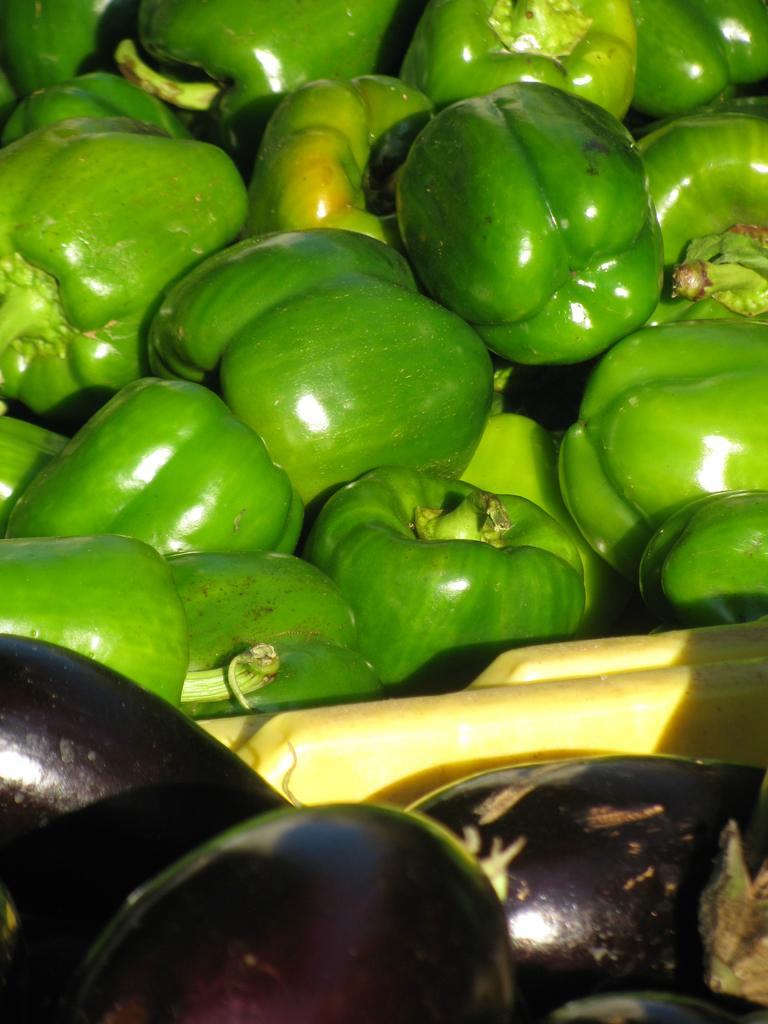What type of vegetables can be seen in the image? There are capsicums and brinjals in the image. How many sheep are visible in the image? There are no sheep present in the image. What form does the self take in the image? The concept of "self" is not applicable to this image, as it only features vegetables. 